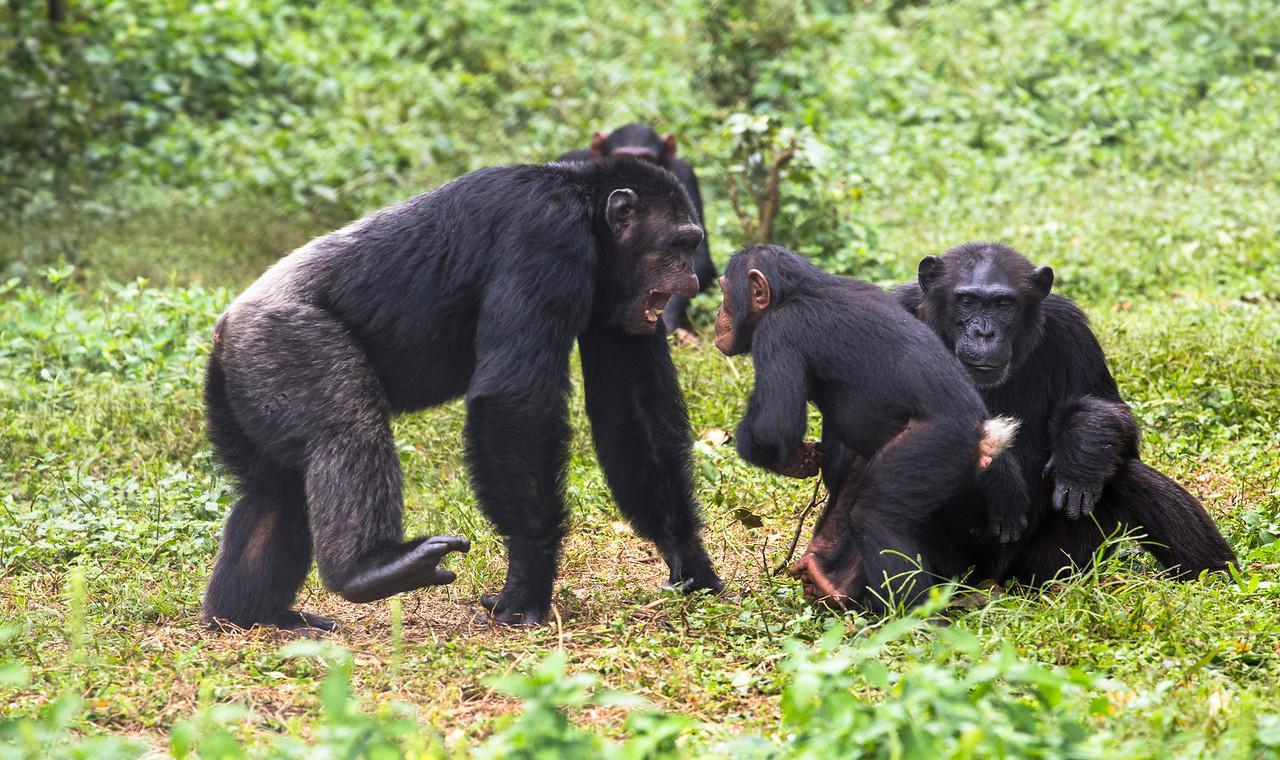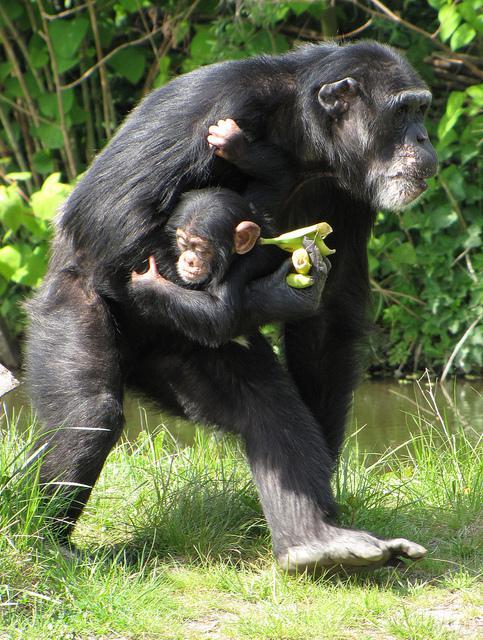The first image is the image on the left, the second image is the image on the right. Evaluate the accuracy of this statement regarding the images: "At least one of the primates is on its hind legs.". Is it true? Answer yes or no. Yes. The first image is the image on the left, the second image is the image on the right. Analyze the images presented: Is the assertion "The left image shows a group of three apes, with a fourth ape in the background." valid? Answer yes or no. Yes. 